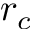<formula> <loc_0><loc_0><loc_500><loc_500>r _ { c }</formula> 